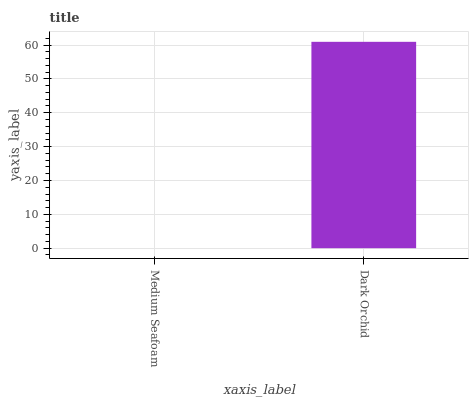Is Medium Seafoam the minimum?
Answer yes or no. Yes. Is Dark Orchid the maximum?
Answer yes or no. Yes. Is Dark Orchid the minimum?
Answer yes or no. No. Is Dark Orchid greater than Medium Seafoam?
Answer yes or no. Yes. Is Medium Seafoam less than Dark Orchid?
Answer yes or no. Yes. Is Medium Seafoam greater than Dark Orchid?
Answer yes or no. No. Is Dark Orchid less than Medium Seafoam?
Answer yes or no. No. Is Dark Orchid the high median?
Answer yes or no. Yes. Is Medium Seafoam the low median?
Answer yes or no. Yes. Is Medium Seafoam the high median?
Answer yes or no. No. Is Dark Orchid the low median?
Answer yes or no. No. 